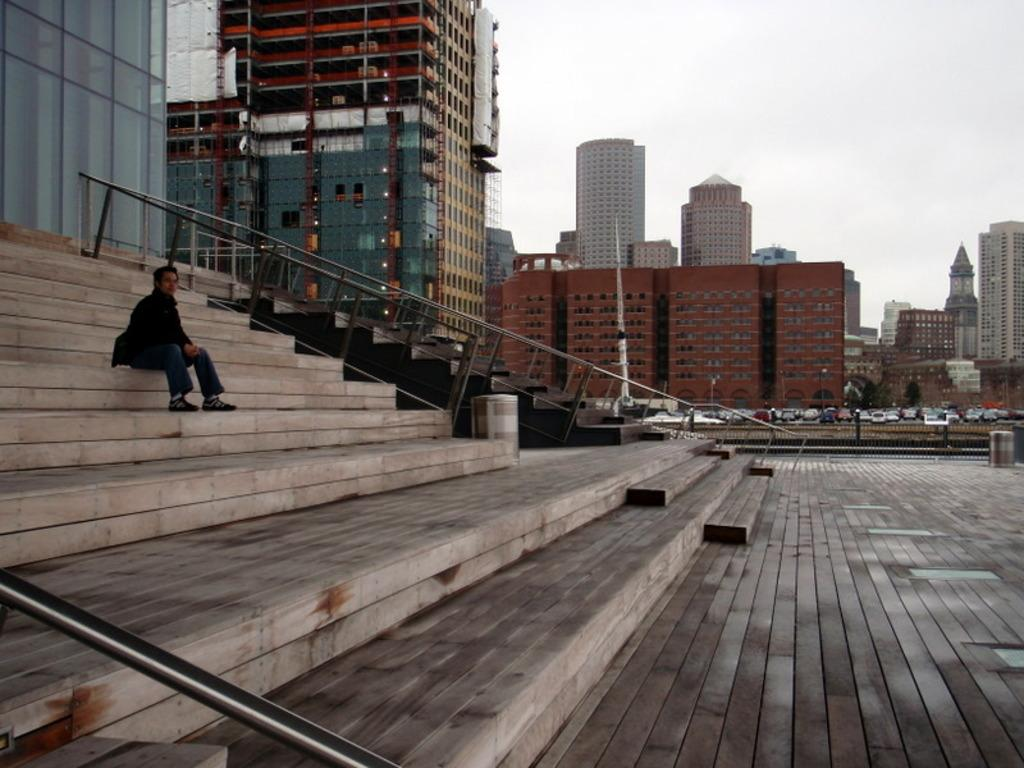What type of structures can be seen in the image? There are buildings in the image. What is the person in the image doing? The person is sitting on the stairs in the image. What can be seen moving on the road in the image? There are vehicles on the road in the image. What type of barrier is present in the image? There is a fence in the image. What vertical object can be seen in the image? There is a pole in the image. What part of the natural environment is visible in the image? The sky is visible in the image. What type of milk is being poured from the pole in the image? There is no milk or pouring action present in the image; the pole is a vertical object. What sound can be heard coming from the person sitting on the stairs in the image? The image is static, so no sound can be heard. 